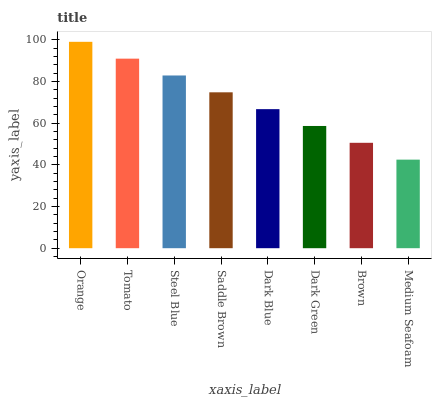Is Medium Seafoam the minimum?
Answer yes or no. Yes. Is Orange the maximum?
Answer yes or no. Yes. Is Tomato the minimum?
Answer yes or no. No. Is Tomato the maximum?
Answer yes or no. No. Is Orange greater than Tomato?
Answer yes or no. Yes. Is Tomato less than Orange?
Answer yes or no. Yes. Is Tomato greater than Orange?
Answer yes or no. No. Is Orange less than Tomato?
Answer yes or no. No. Is Saddle Brown the high median?
Answer yes or no. Yes. Is Dark Blue the low median?
Answer yes or no. Yes. Is Dark Blue the high median?
Answer yes or no. No. Is Dark Green the low median?
Answer yes or no. No. 